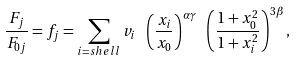<formula> <loc_0><loc_0><loc_500><loc_500>\frac { F _ { j } } { F _ { 0 j } } = f _ { j } = \sum _ { i = s h e l l } v _ { i } \ \left ( \frac { x _ { i } } { x _ { 0 } } \right ) ^ { \alpha \gamma } \ \left ( \frac { 1 + x _ { 0 } ^ { 2 } } { 1 + x _ { i } ^ { 2 } } \right ) ^ { 3 \beta } ,</formula> 